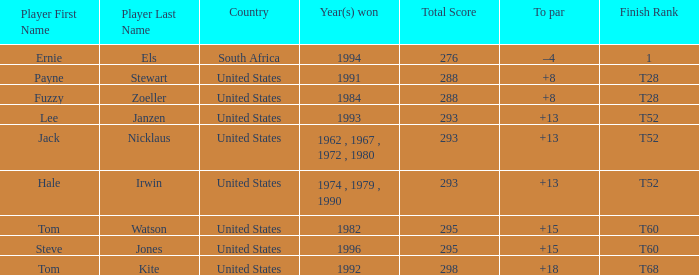What year did player steve jones, who had a t60 finish, win? 1996.0. 